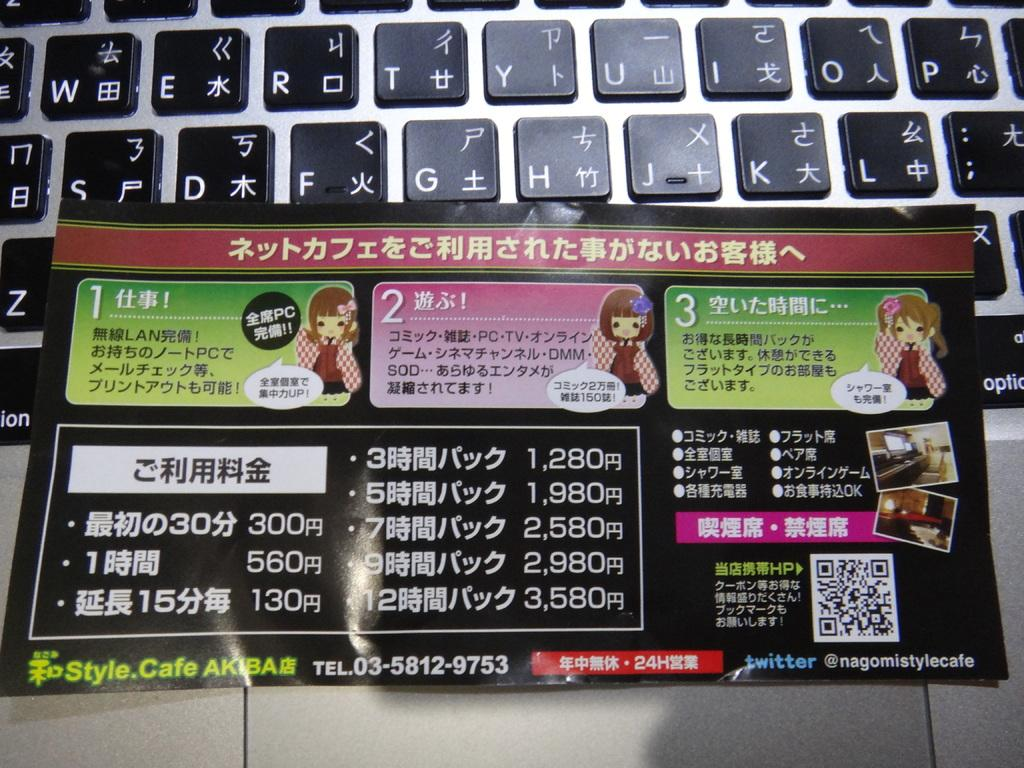Provide a one-sentence caption for the provided image. A Chinese instruction leaflet sits on a computer keybopard that has normal letters and chinese writing on its keys. 